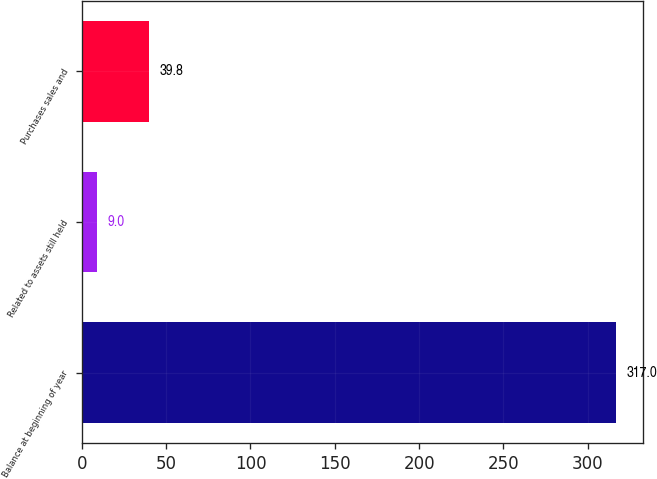Convert chart to OTSL. <chart><loc_0><loc_0><loc_500><loc_500><bar_chart><fcel>Balance at beginning of year<fcel>Related to assets still held<fcel>Purchases sales and<nl><fcel>317<fcel>9<fcel>39.8<nl></chart> 